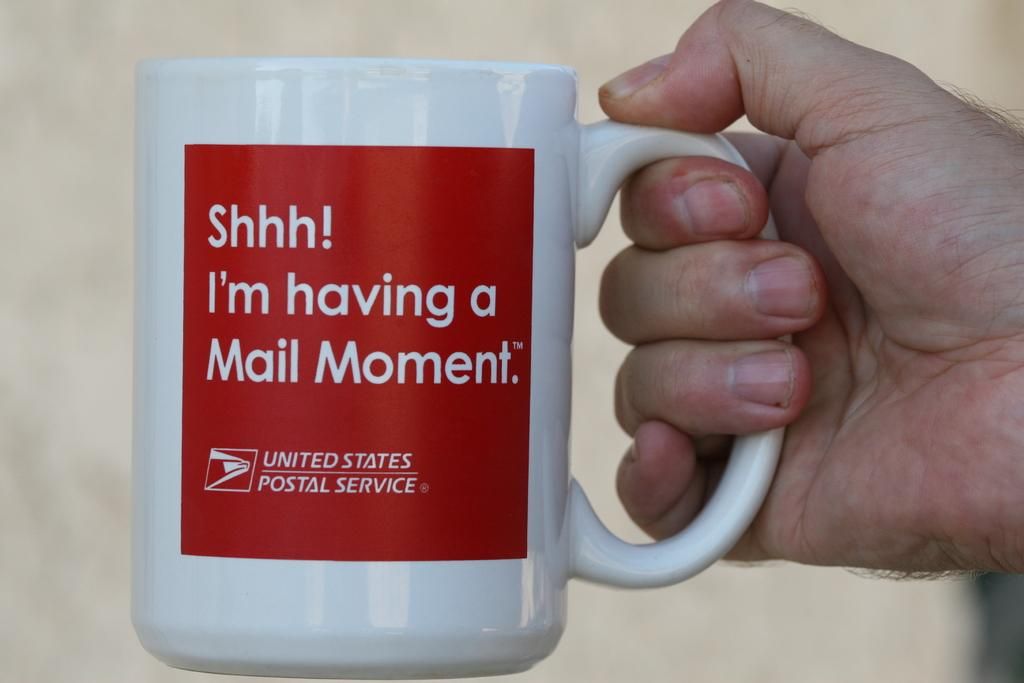<image>
Describe the image concisely. A mail theme slogan is shown on a United States Postal Service coffee mug held in a man's hand. 